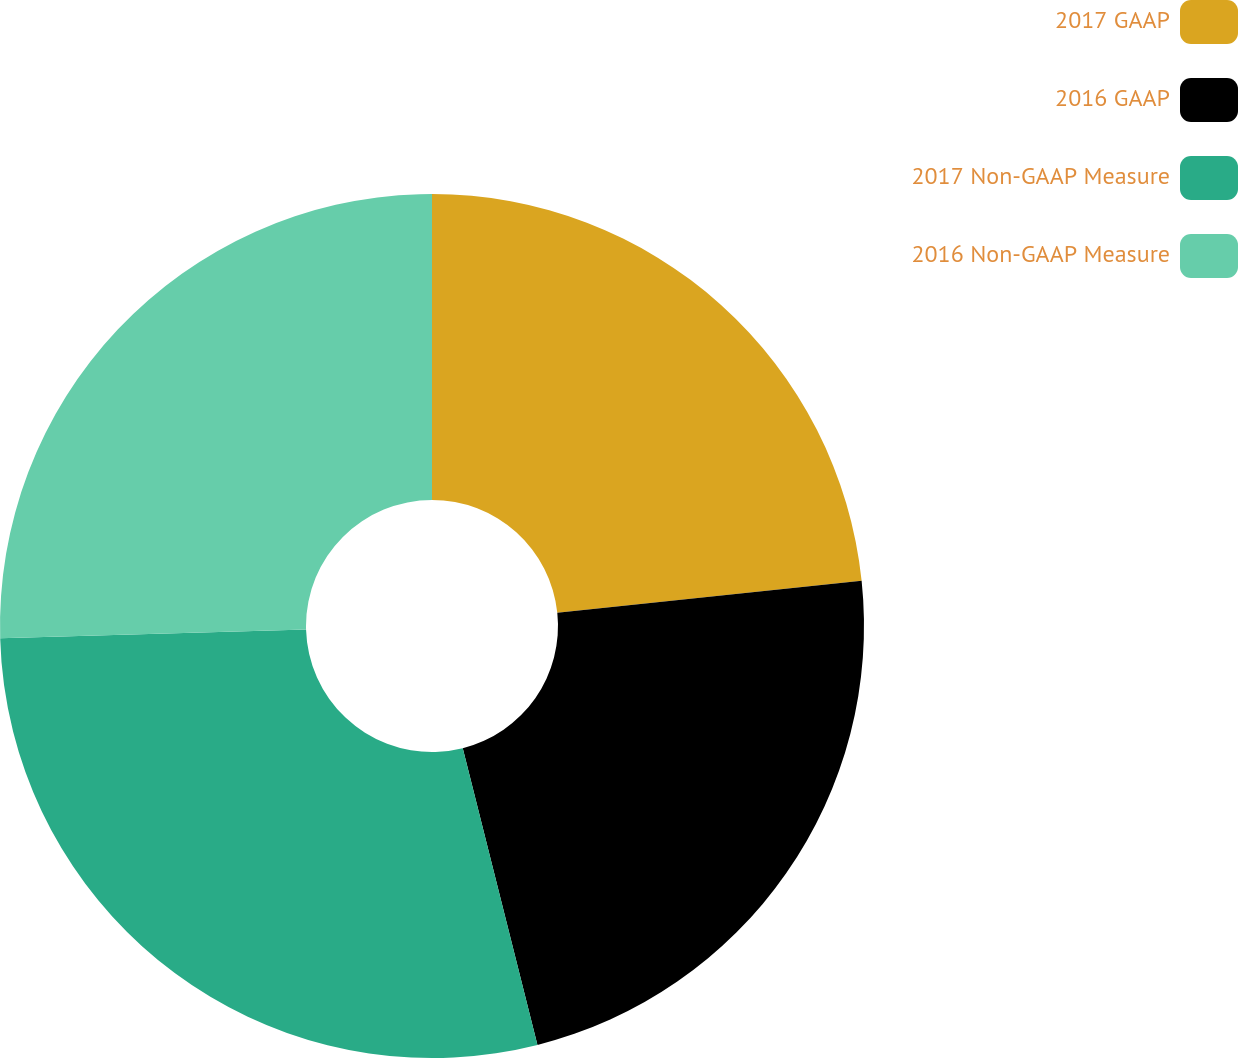<chart> <loc_0><loc_0><loc_500><loc_500><pie_chart><fcel>2017 GAAP<fcel>2016 GAAP<fcel>2017 Non-GAAP Measure<fcel>2016 Non-GAAP Measure<nl><fcel>23.33%<fcel>22.74%<fcel>28.47%<fcel>25.45%<nl></chart> 